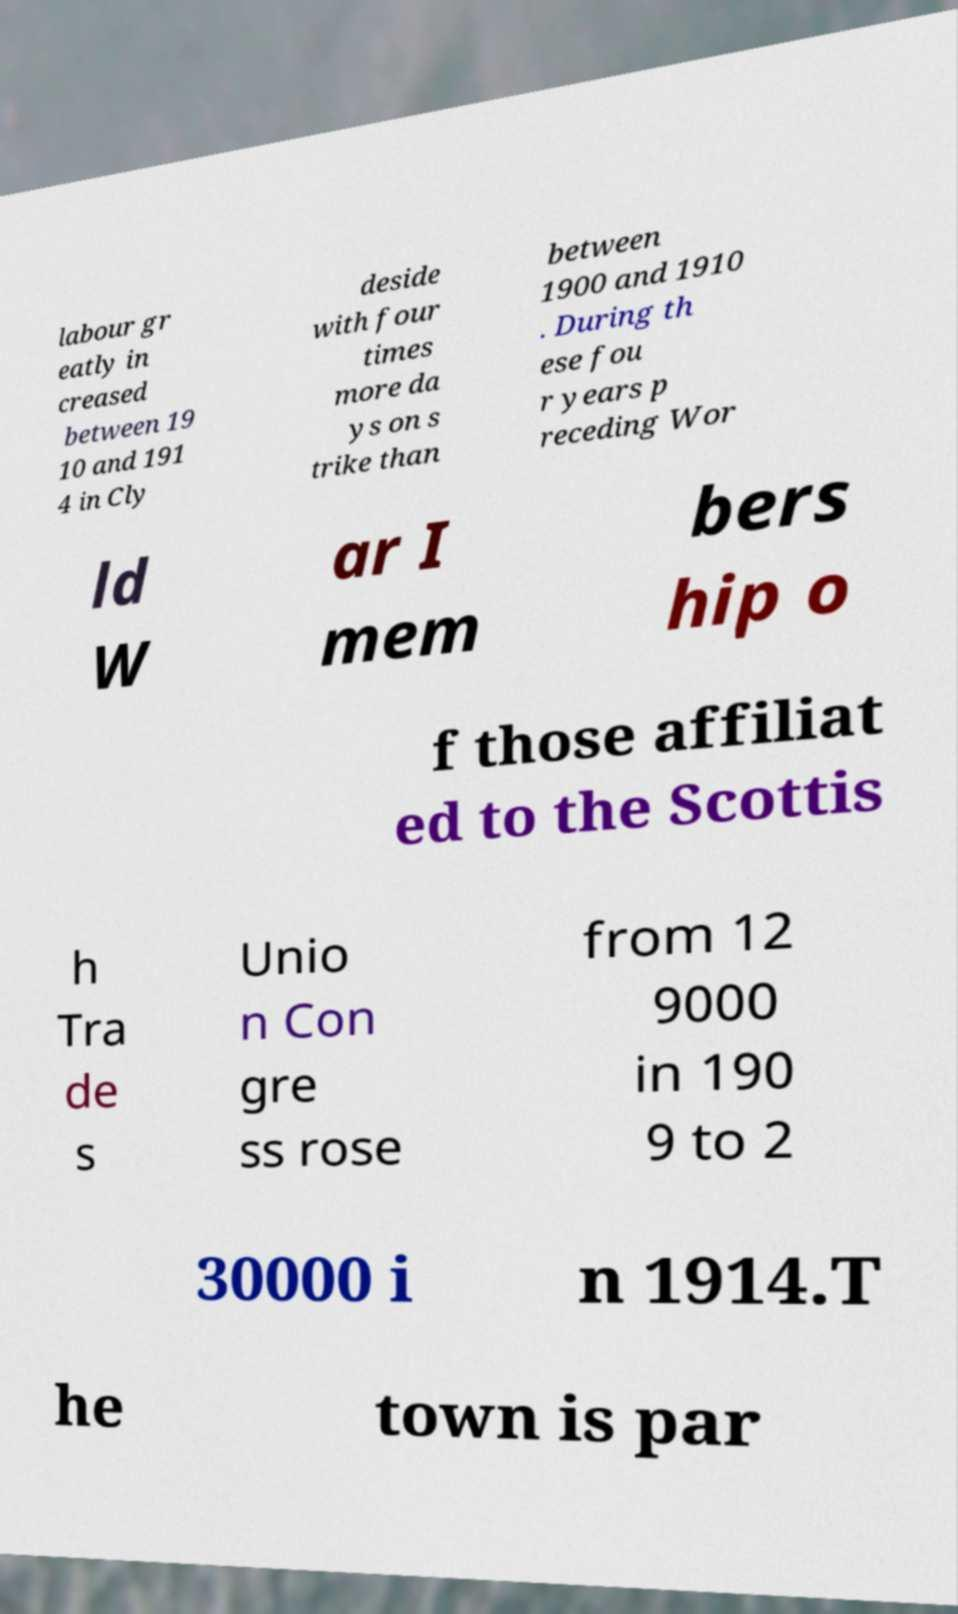Can you accurately transcribe the text from the provided image for me? labour gr eatly in creased between 19 10 and 191 4 in Cly deside with four times more da ys on s trike than between 1900 and 1910 . During th ese fou r years p receding Wor ld W ar I mem bers hip o f those affiliat ed to the Scottis h Tra de s Unio n Con gre ss rose from 12 9000 in 190 9 to 2 30000 i n 1914.T he town is par 